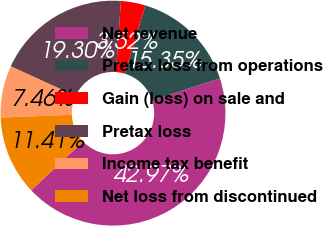Convert chart. <chart><loc_0><loc_0><loc_500><loc_500><pie_chart><fcel>Net revenue<fcel>Pretax loss from operations<fcel>Gain (loss) on sale and<fcel>Pretax loss<fcel>Income tax benefit<fcel>Net loss from discontinued<nl><fcel>42.97%<fcel>15.35%<fcel>3.52%<fcel>19.3%<fcel>7.46%<fcel>11.41%<nl></chart> 